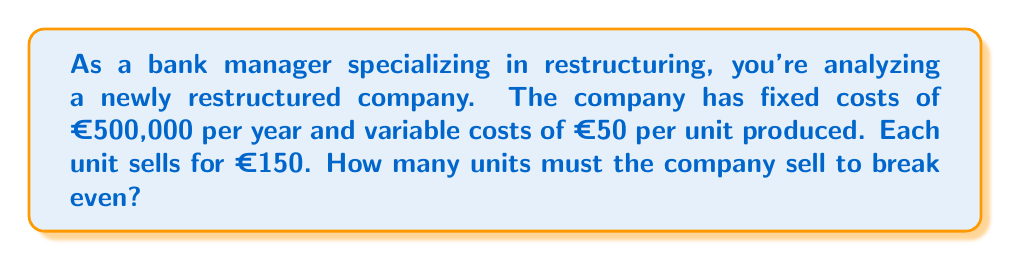Show me your answer to this math problem. To solve this problem, we need to understand the concept of the break-even point and use the break-even formula. The break-even point is where total revenue equals total costs, resulting in zero profit.

Let's define our variables:
$F$ = Fixed costs = €500,000
$V$ = Variable cost per unit = €50
$P$ = Price per unit = €150
$X$ = Number of units to break even

The break-even formula is:

$$ \text{Total Revenue} = \text{Total Costs} $$
$$ PX = F + VX $$

Now, let's substitute our values:

$$ 150X = 500,000 + 50X $$

To solve for $X$, we need to isolate it on one side of the equation:

$$ 150X - 50X = 500,000 $$
$$ 100X = 500,000 $$

Now we can divide both sides by 100:

$$ X = \frac{500,000}{100} = 5,000 $$

Therefore, the company needs to sell 5,000 units to break even.

To verify:
Revenue at 5,000 units: $5,000 \times €150 = €750,000$
Total costs at 5,000 units: $€500,000 + (5,000 \times €50) = €750,000$

As we can see, at 5,000 units, revenue equals total costs, confirming the break-even point.
Answer: The company must sell 5,000 units to break even. 